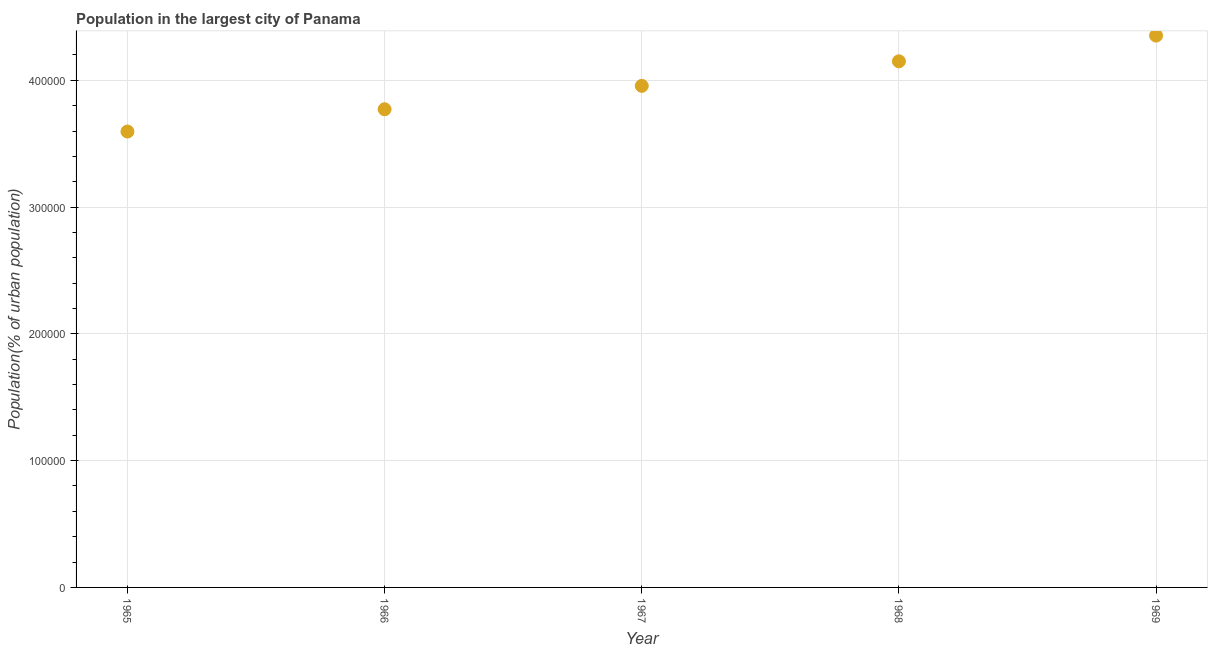What is the population in largest city in 1968?
Offer a terse response. 4.15e+05. Across all years, what is the maximum population in largest city?
Your response must be concise. 4.35e+05. Across all years, what is the minimum population in largest city?
Provide a succinct answer. 3.60e+05. In which year was the population in largest city maximum?
Offer a terse response. 1969. In which year was the population in largest city minimum?
Offer a very short reply. 1965. What is the sum of the population in largest city?
Provide a short and direct response. 1.98e+06. What is the difference between the population in largest city in 1968 and 1969?
Your answer should be compact. -2.03e+04. What is the average population in largest city per year?
Offer a very short reply. 3.97e+05. What is the median population in largest city?
Keep it short and to the point. 3.96e+05. Do a majority of the years between 1968 and 1966 (inclusive) have population in largest city greater than 220000 %?
Offer a very short reply. No. What is the ratio of the population in largest city in 1965 to that in 1966?
Ensure brevity in your answer.  0.95. Is the difference between the population in largest city in 1967 and 1969 greater than the difference between any two years?
Your answer should be very brief. No. What is the difference between the highest and the second highest population in largest city?
Your answer should be very brief. 2.03e+04. Is the sum of the population in largest city in 1967 and 1968 greater than the maximum population in largest city across all years?
Provide a short and direct response. Yes. What is the difference between the highest and the lowest population in largest city?
Make the answer very short. 7.57e+04. Does the population in largest city monotonically increase over the years?
Make the answer very short. Yes. How many dotlines are there?
Ensure brevity in your answer.  1. What is the difference between two consecutive major ticks on the Y-axis?
Keep it short and to the point. 1.00e+05. Does the graph contain grids?
Make the answer very short. Yes. What is the title of the graph?
Your response must be concise. Population in the largest city of Panama. What is the label or title of the Y-axis?
Ensure brevity in your answer.  Population(% of urban population). What is the Population(% of urban population) in 1965?
Your answer should be very brief. 3.60e+05. What is the Population(% of urban population) in 1966?
Provide a succinct answer. 3.77e+05. What is the Population(% of urban population) in 1967?
Offer a very short reply. 3.96e+05. What is the Population(% of urban population) in 1968?
Your answer should be compact. 4.15e+05. What is the Population(% of urban population) in 1969?
Give a very brief answer. 4.35e+05. What is the difference between the Population(% of urban population) in 1965 and 1966?
Your response must be concise. -1.76e+04. What is the difference between the Population(% of urban population) in 1965 and 1967?
Offer a terse response. -3.60e+04. What is the difference between the Population(% of urban population) in 1965 and 1968?
Your answer should be compact. -5.54e+04. What is the difference between the Population(% of urban population) in 1965 and 1969?
Ensure brevity in your answer.  -7.57e+04. What is the difference between the Population(% of urban population) in 1966 and 1967?
Provide a short and direct response. -1.84e+04. What is the difference between the Population(% of urban population) in 1966 and 1968?
Provide a succinct answer. -3.78e+04. What is the difference between the Population(% of urban population) in 1966 and 1969?
Give a very brief answer. -5.81e+04. What is the difference between the Population(% of urban population) in 1967 and 1968?
Your response must be concise. -1.94e+04. What is the difference between the Population(% of urban population) in 1967 and 1969?
Ensure brevity in your answer.  -3.96e+04. What is the difference between the Population(% of urban population) in 1968 and 1969?
Provide a succinct answer. -2.03e+04. What is the ratio of the Population(% of urban population) in 1965 to that in 1966?
Make the answer very short. 0.95. What is the ratio of the Population(% of urban population) in 1965 to that in 1967?
Your answer should be very brief. 0.91. What is the ratio of the Population(% of urban population) in 1965 to that in 1968?
Your response must be concise. 0.87. What is the ratio of the Population(% of urban population) in 1965 to that in 1969?
Keep it short and to the point. 0.83. What is the ratio of the Population(% of urban population) in 1966 to that in 1967?
Your response must be concise. 0.95. What is the ratio of the Population(% of urban population) in 1966 to that in 1968?
Your answer should be compact. 0.91. What is the ratio of the Population(% of urban population) in 1966 to that in 1969?
Your response must be concise. 0.87. What is the ratio of the Population(% of urban population) in 1967 to that in 1968?
Provide a short and direct response. 0.95. What is the ratio of the Population(% of urban population) in 1967 to that in 1969?
Your response must be concise. 0.91. What is the ratio of the Population(% of urban population) in 1968 to that in 1969?
Provide a short and direct response. 0.95. 